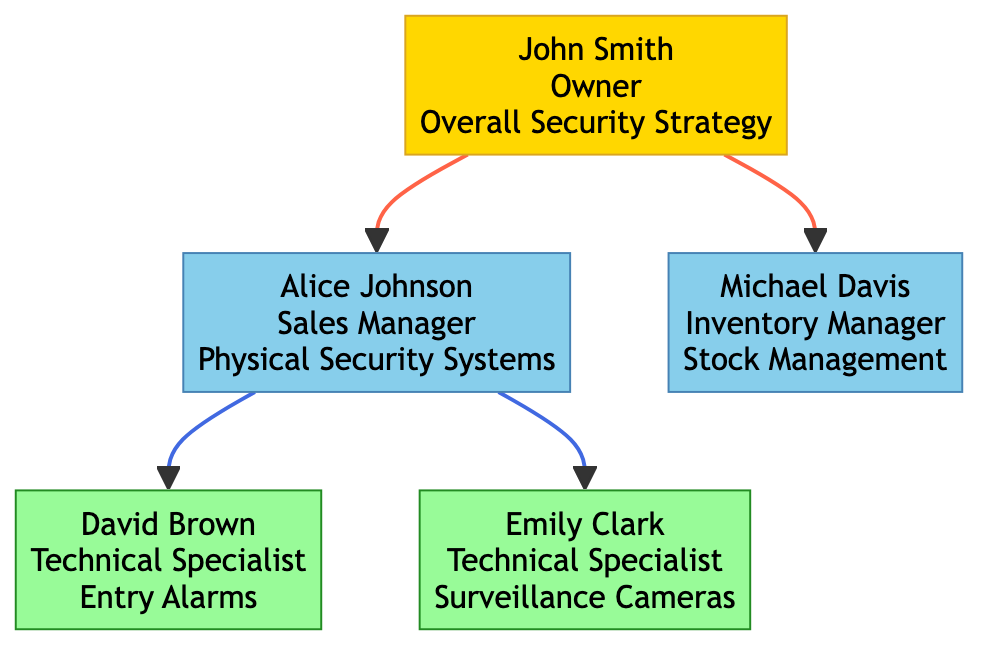What's the specialization of David Brown? David Brown is identified in the diagram as a Technical Specialist with a specialization in Entry Alarms. This information is directly stated under his node.
Answer: Entry Alarms Who reports to Alice Johnson? From the diagram, David Brown and Emily Clark are both shown as reporting to Alice Johnson, as they are directly connected to her node.
Answer: David Brown, Emily Clark How many managers are there in the diagram? The diagram displays two nodes labeled as managers: Alice Johnson (Sales Manager) and Michael Davis (Inventory Manager), indicating that there are two managers.
Answer: 2 What is the role of Michael Davis? The diagram indicates that Michael Davis has several roles, including Inventory Tracking, Supplier Coordination, and Restocking. These roles are listed under his node.
Answer: Inventory Tracking, Supplier Coordination, Restocking Which employee specializes in Surveillance Cameras? Emily Clark is the employee identified in the diagram as specializing in Surveillance Cameras. This is explicitly stated in her node under specialization.
Answer: Emily Clark Who has the highest level of authority? The diagram shows that John Smith, the Owner, does not report to anyone, indicating he holds the highest level of authority in the hierarchy.
Answer: John Smith What is the relationship between John Smith and Alice Johnson? Alice Johnson is directly connected to John Smith in the diagram, showing that she reports to him, establishing a hierarchical relationship where John Smith is her superior.
Answer: John Smith is superior to Alice Johnson How many specialized areas of knowledge are represented in the diagram? The diagram includes three specialized areas of knowledge: Overall Security Strategy (John Smith), Physical Security Systems (Alice Johnson), Entry Alarms (David Brown), and Surveillance Cameras (Emily Clark), totaling four areas.
Answer: 4 